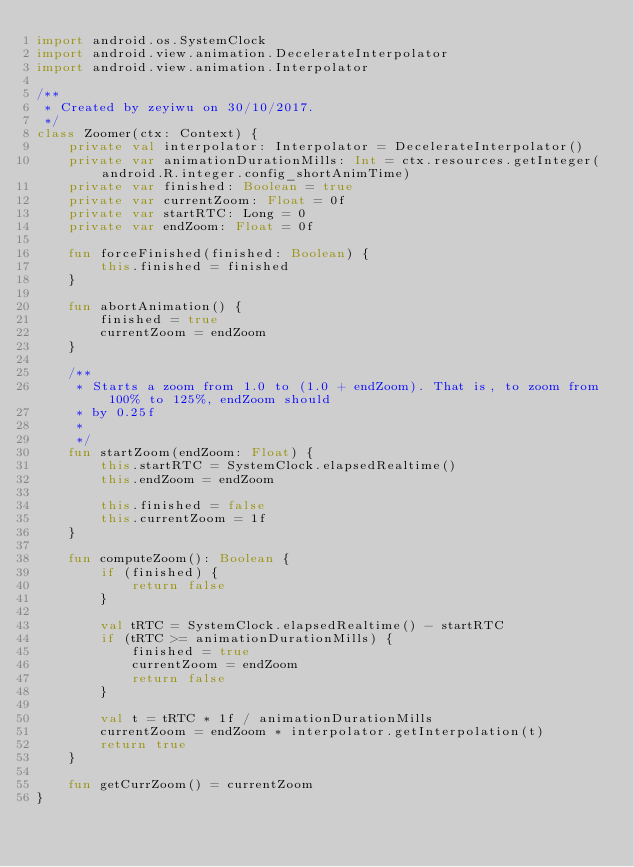Convert code to text. <code><loc_0><loc_0><loc_500><loc_500><_Kotlin_>import android.os.SystemClock
import android.view.animation.DecelerateInterpolator
import android.view.animation.Interpolator

/**
 * Created by zeyiwu on 30/10/2017.
 */
class Zoomer(ctx: Context) {
    private val interpolator: Interpolator = DecelerateInterpolator()
    private var animationDurationMills: Int = ctx.resources.getInteger(android.R.integer.config_shortAnimTime)
    private var finished: Boolean = true
    private var currentZoom: Float = 0f
    private var startRTC: Long = 0
    private var endZoom: Float = 0f

    fun forceFinished(finished: Boolean) {
        this.finished = finished
    }

    fun abortAnimation() {
        finished = true
        currentZoom = endZoom
    }

    /**
     * Starts a zoom from 1.0 to (1.0 + endZoom). That is, to zoom from 100% to 125%, endZoom should
     * by 0.25f
     *
     */
    fun startZoom(endZoom: Float) {
        this.startRTC = SystemClock.elapsedRealtime()
        this.endZoom = endZoom

        this.finished = false
        this.currentZoom = 1f
    }

    fun computeZoom(): Boolean {
        if (finished) {
            return false
        }

        val tRTC = SystemClock.elapsedRealtime() - startRTC
        if (tRTC >= animationDurationMills) {
            finished = true
            currentZoom = endZoom
            return false
        }

        val t = tRTC * 1f / animationDurationMills
        currentZoom = endZoom * interpolator.getInterpolation(t)
        return true
    }

    fun getCurrZoom() = currentZoom
}</code> 